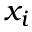Convert formula to latex. <formula><loc_0><loc_0><loc_500><loc_500>x _ { i }</formula> 